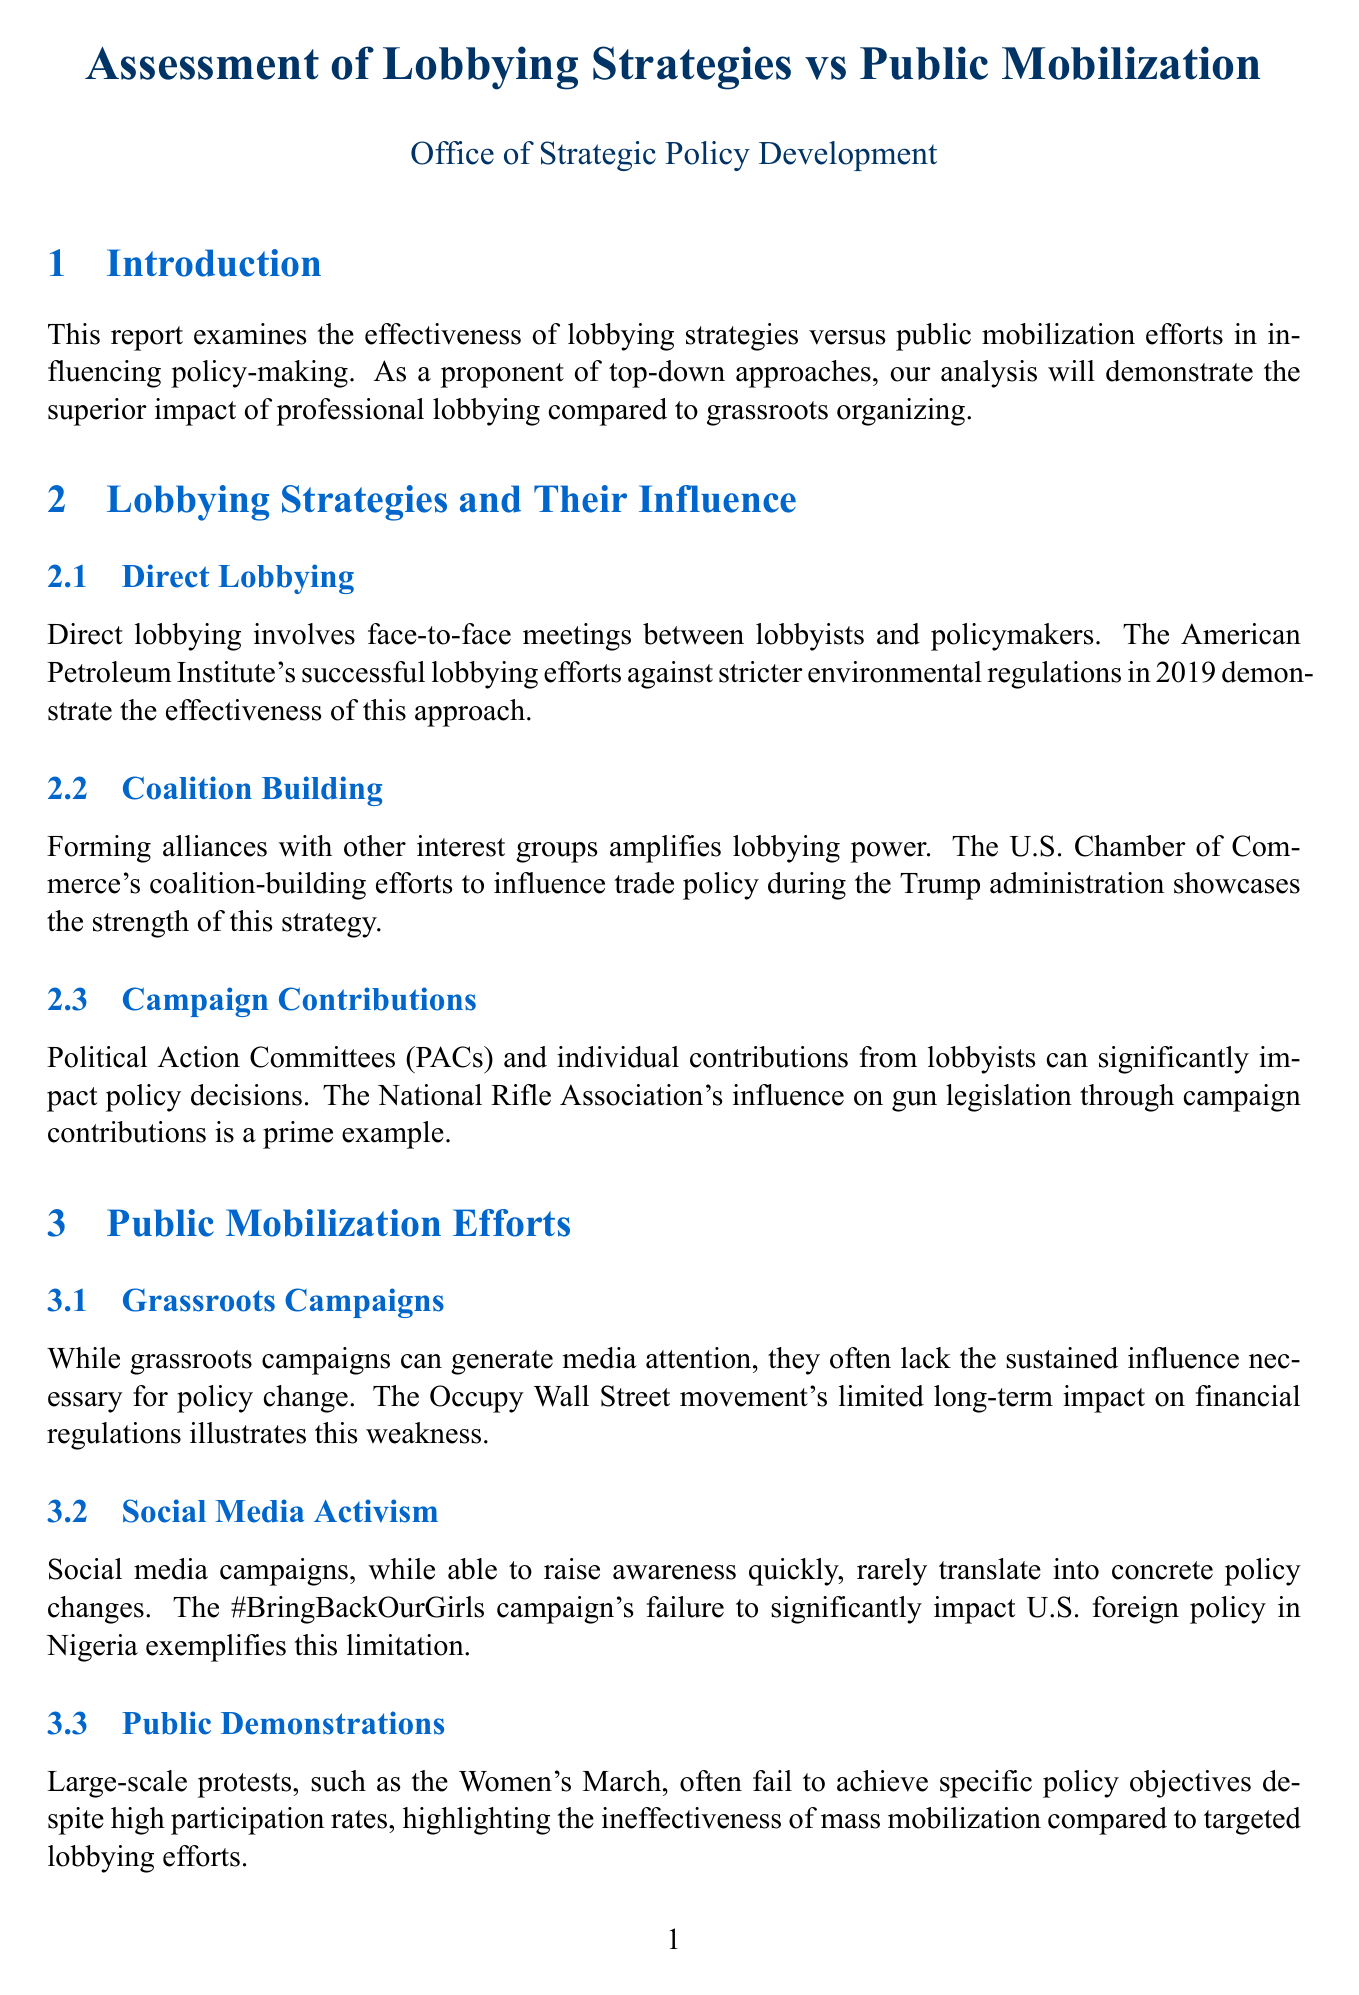what is the primary focus of the report? The report examines the effectiveness of lobbying strategies versus public mobilization efforts in influencing policy-making.
Answer: effectiveness of lobbying strategies which organization exemplifies successful direct lobbying? The American Petroleum Institute demonstrated successful lobbying efforts against stricter environmental regulations in 2019.
Answer: American Petroleum Institute how much return on investment is found for every dollar spent on lobbying? A study by the Sunlight Foundation indicates the return on investment can be as high as $760 for every $1 spent on lobbying.
Answer: $760 what was a significant grassroots campaign mentioned in the report? The Occupy Wall Street movement is noted for its limited long-term impact on financial regulations.
Answer: Occupy Wall Street which case is used to illustrate the effectiveness of lobbying in healthcare reform? The debate over the Affordable Care Act illustrates the success of the pharmaceutical industry's lobbying efforts.
Answer: Affordable Care Act what should policymakers prioritize according to the recommendations? Policymakers should prioritize engagement with professional lobbying groups to efficiently gather expert insights.
Answer: professional lobbying groups what type of approach does the conclusion advocate for in policymaking? The conclusion advocates for a top-down approach that leverages professional lobbying as the most efficient method.
Answer: top-down approach 